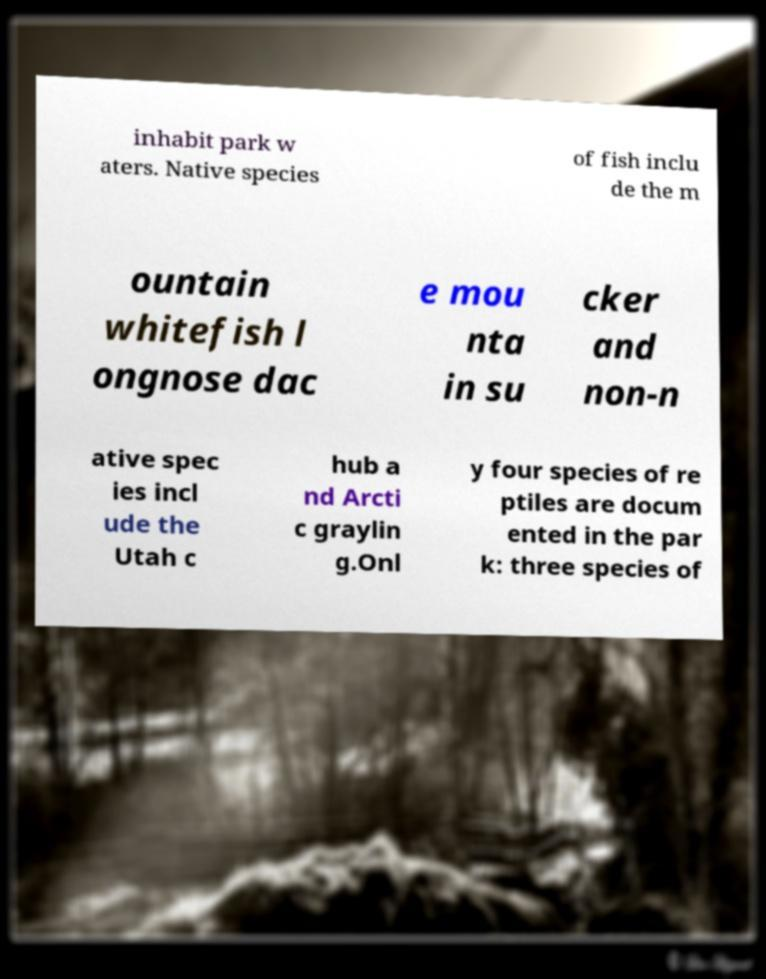Please identify and transcribe the text found in this image. inhabit park w aters. Native species of fish inclu de the m ountain whitefish l ongnose dac e mou nta in su cker and non-n ative spec ies incl ude the Utah c hub a nd Arcti c graylin g.Onl y four species of re ptiles are docum ented in the par k: three species of 